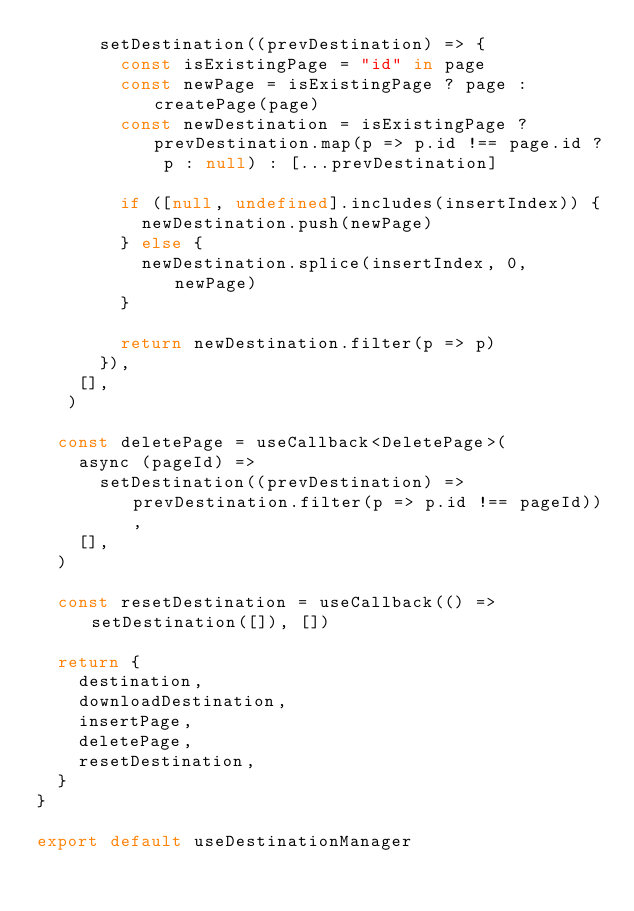Convert code to text. <code><loc_0><loc_0><loc_500><loc_500><_TypeScript_>      setDestination((prevDestination) => {
        const isExistingPage = "id" in page
        const newPage = isExistingPage ? page : createPage(page)
        const newDestination = isExistingPage ? prevDestination.map(p => p.id !== page.id ? p : null) : [...prevDestination]

        if ([null, undefined].includes(insertIndex)) {
          newDestination.push(newPage)
        } else {
          newDestination.splice(insertIndex, 0, newPage)
        }

        return newDestination.filter(p => p)
      }),
    [],
   )

  const deletePage = useCallback<DeletePage>(
    async (pageId) =>
      setDestination((prevDestination) => prevDestination.filter(p => p.id !== pageId)),
    [],
  )

  const resetDestination = useCallback(() => setDestination([]), [])

  return {
    destination,
    downloadDestination,
    insertPage,
    deletePage,
    resetDestination,
  }
}

export default useDestinationManager
</code> 